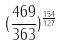Convert formula to latex. <formula><loc_0><loc_0><loc_500><loc_500>( \frac { 4 6 9 } { 3 6 3 } ) ^ { \frac { 1 5 4 } { 1 2 7 } }</formula> 